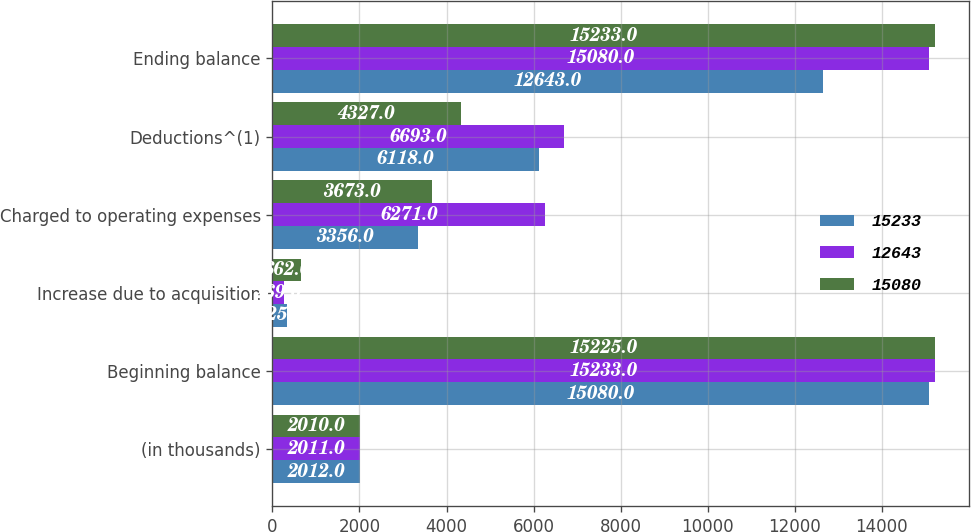<chart> <loc_0><loc_0><loc_500><loc_500><stacked_bar_chart><ecel><fcel>(in thousands)<fcel>Beginning balance<fcel>Increase due to acquisition<fcel>Charged to operating expenses<fcel>Deductions^(1)<fcel>Ending balance<nl><fcel>15233<fcel>2012<fcel>15080<fcel>325<fcel>3356<fcel>6118<fcel>12643<nl><fcel>12643<fcel>2011<fcel>15233<fcel>269<fcel>6271<fcel>6693<fcel>15080<nl><fcel>15080<fcel>2010<fcel>15225<fcel>662<fcel>3673<fcel>4327<fcel>15233<nl></chart> 